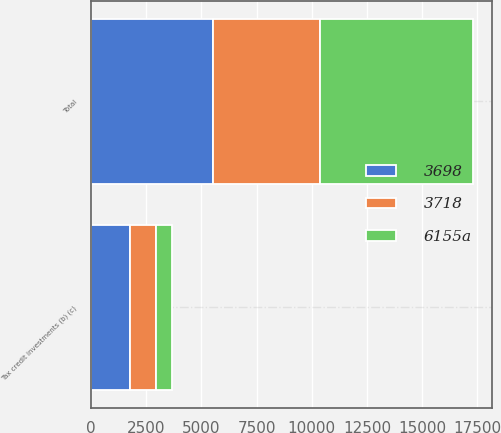Convert chart to OTSL. <chart><loc_0><loc_0><loc_500><loc_500><stacked_bar_chart><ecel><fcel>Tax credit investments (b) (c)<fcel>Total<nl><fcel>3698<fcel>1786<fcel>5507<nl><fcel>3718<fcel>1156<fcel>4874<nl><fcel>6155a<fcel>743<fcel>6900<nl></chart> 